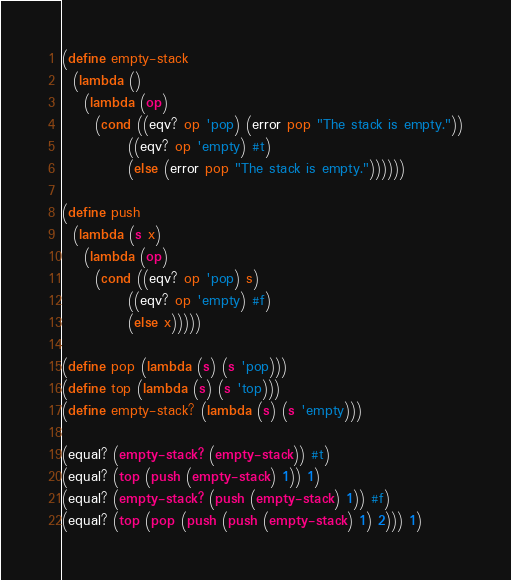Convert code to text. <code><loc_0><loc_0><loc_500><loc_500><_Scheme_>(define empty-stack
  (lambda ()
    (lambda (op)
      (cond ((eqv? op 'pop) (error pop "The stack is empty."))
            ((eqv? op 'empty) #t)
            (else (error pop "The stack is empty."))))))

(define push
  (lambda (s x)
    (lambda (op)
      (cond ((eqv? op 'pop) s)
            ((eqv? op 'empty) #f)
            (else x)))))

(define pop (lambda (s) (s 'pop)))
(define top (lambda (s) (s 'top)))
(define empty-stack? (lambda (s) (s 'empty)))

(equal? (empty-stack? (empty-stack)) #t)
(equal? (top (push (empty-stack) 1)) 1)
(equal? (empty-stack? (push (empty-stack) 1)) #f)
(equal? (top (pop (push (push (empty-stack) 1) 2))) 1)
</code> 